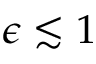<formula> <loc_0><loc_0><loc_500><loc_500>\epsilon \lesssim 1</formula> 